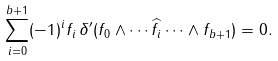<formula> <loc_0><loc_0><loc_500><loc_500>\sum _ { i = 0 } ^ { b + 1 } ( - 1 ) ^ { i } f _ { i } \, \delta ^ { \prime } ( f _ { 0 } \wedge \cdots \widehat { f _ { i } } \cdots \wedge f _ { b + 1 } ) = 0 .</formula> 